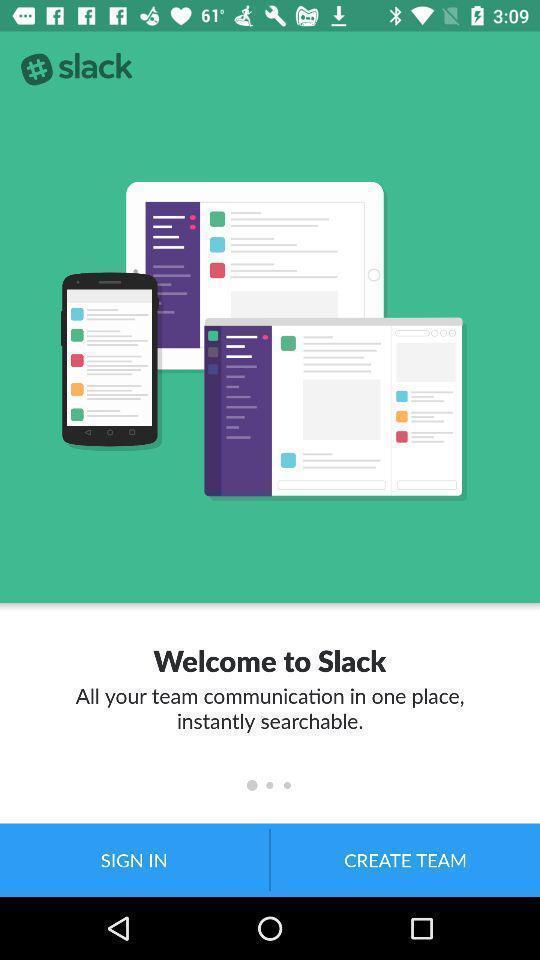Provide a description of this screenshot. Welcome page of social app. 